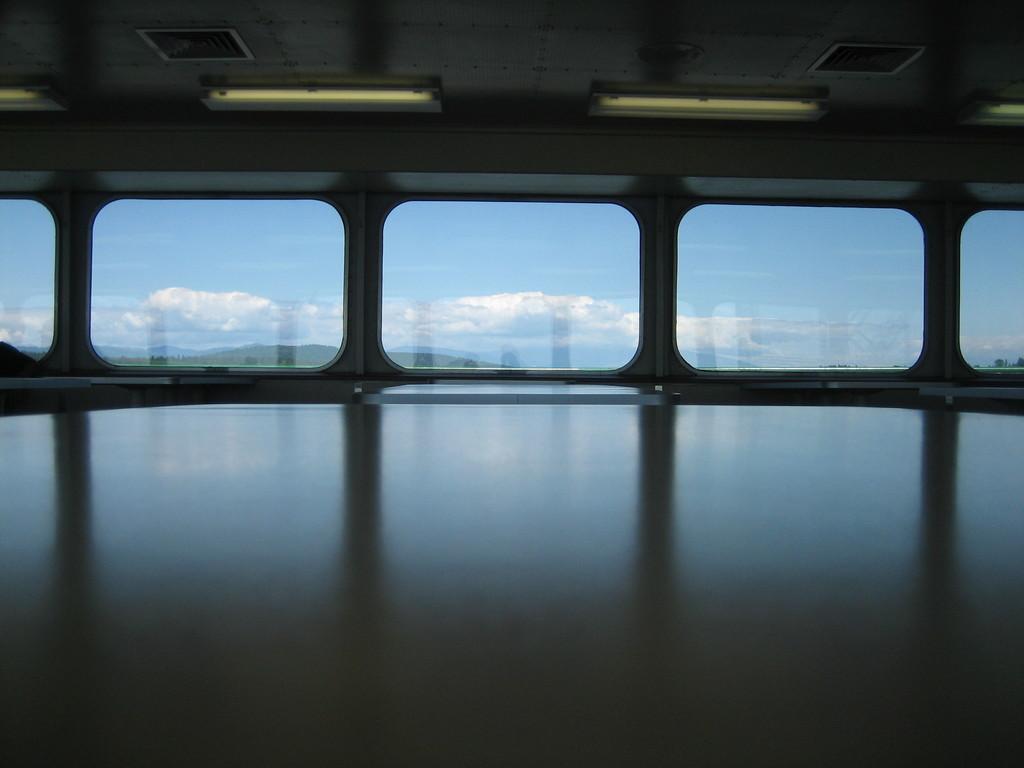How would you summarize this image in a sentence or two? In this image we can see tables. At the top of the image there is ceiling with lights. In the background of the image there is glass through which we can see sky and clouds. 